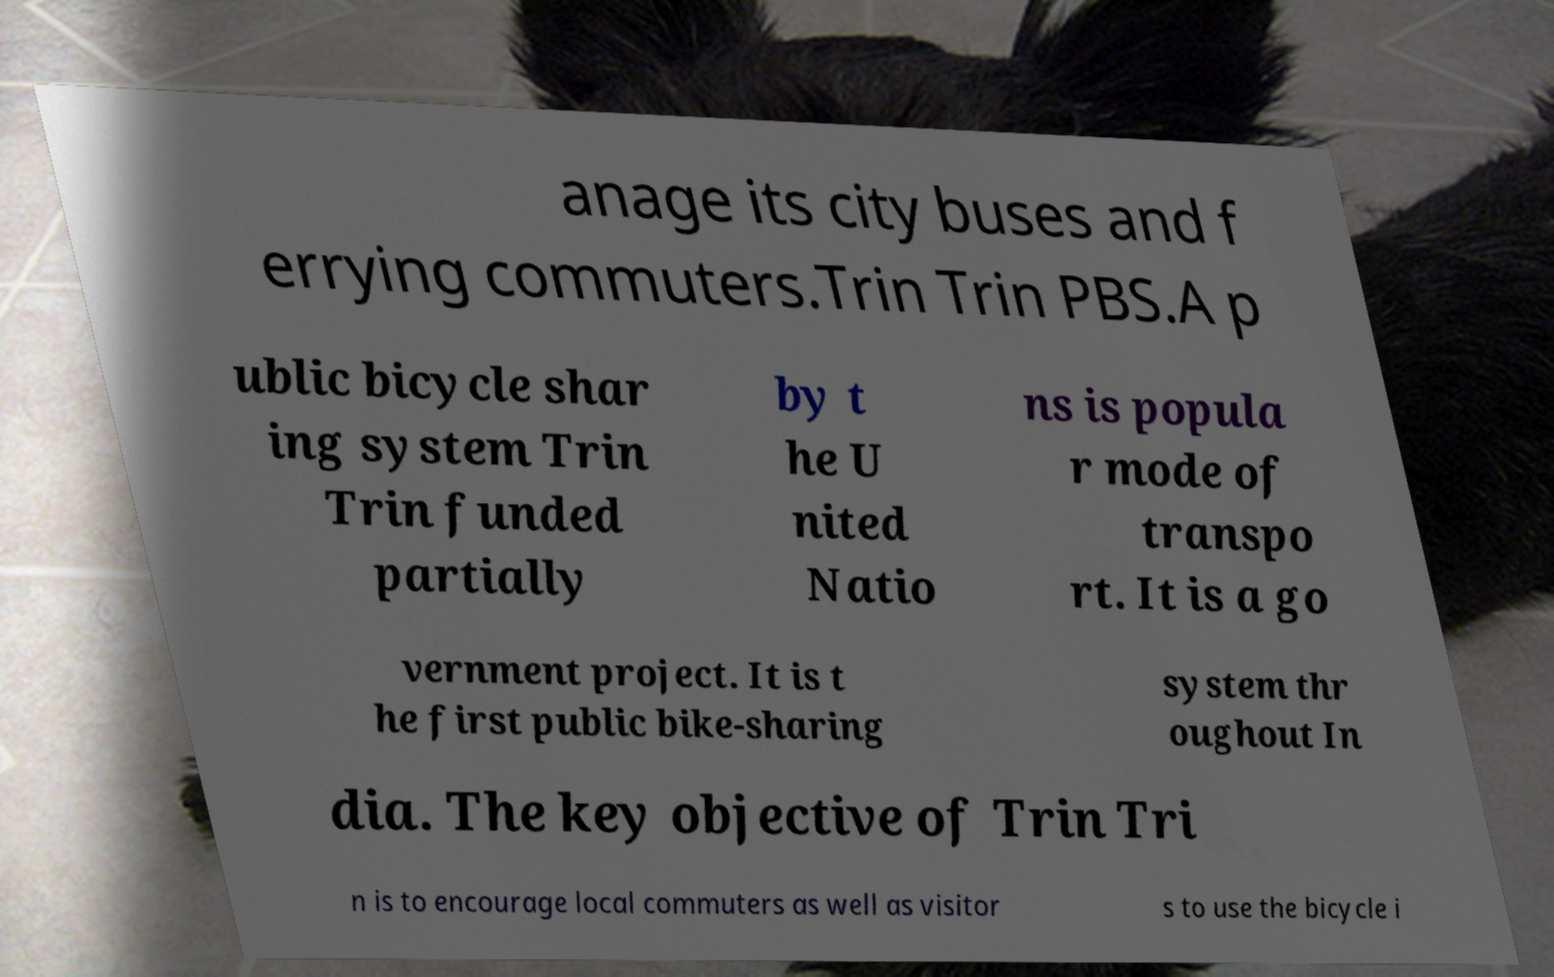There's text embedded in this image that I need extracted. Can you transcribe it verbatim? anage its city buses and f errying commuters.Trin Trin PBS.A p ublic bicycle shar ing system Trin Trin funded partially by t he U nited Natio ns is popula r mode of transpo rt. It is a go vernment project. It is t he first public bike-sharing system thr oughout In dia. The key objective of Trin Tri n is to encourage local commuters as well as visitor s to use the bicycle i 